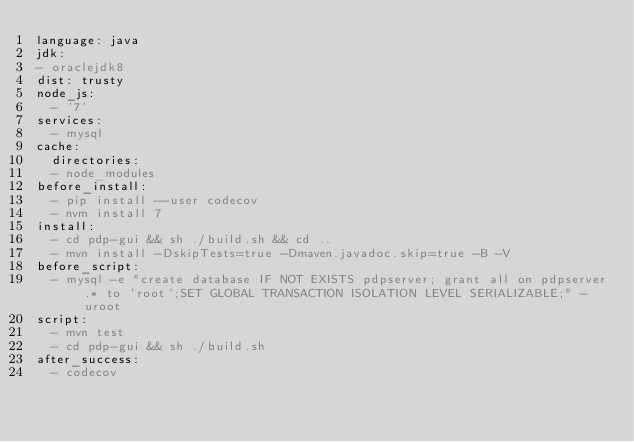<code> <loc_0><loc_0><loc_500><loc_500><_YAML_>language: java
jdk:
- oraclejdk8
dist: trusty
node_js:
  - '7'
services:
  - mysql
cache:
  directories:
  - node_modules
before_install:
  - pip install --user codecov
  - nvm install 7
install:
  - cd pdp-gui && sh ./build.sh && cd ..
  - mvn install -DskipTests=true -Dmaven.javadoc.skip=true -B -V
before_script:
  - mysql -e "create database IF NOT EXISTS pdpserver; grant all on pdpserver.* to 'root';SET GLOBAL TRANSACTION ISOLATION LEVEL SERIALIZABLE;" -uroot
script:
  - mvn test
  - cd pdp-gui && sh ./build.sh
after_success:
  - codecov
</code> 